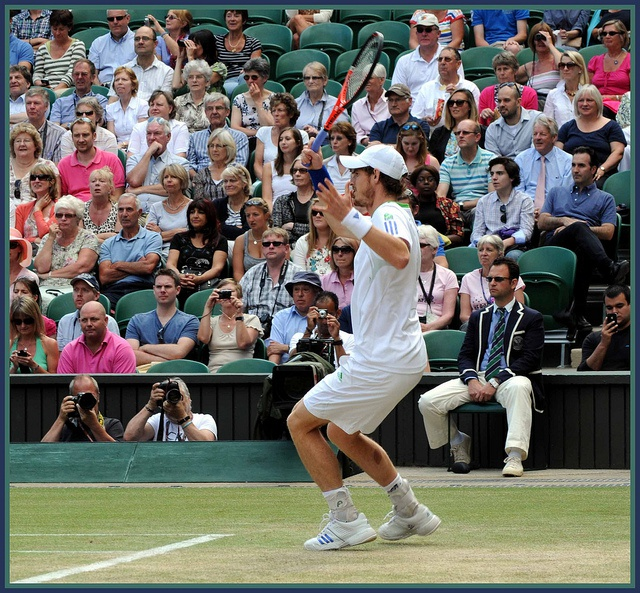Describe the objects in this image and their specific colors. I can see people in navy, black, gray, darkgray, and brown tones, people in navy, darkgray, lightgray, olive, and gray tones, people in navy, black, ivory, gray, and darkgray tones, chair in navy, black, teal, and darkgreen tones, and people in navy, black, and gray tones in this image. 